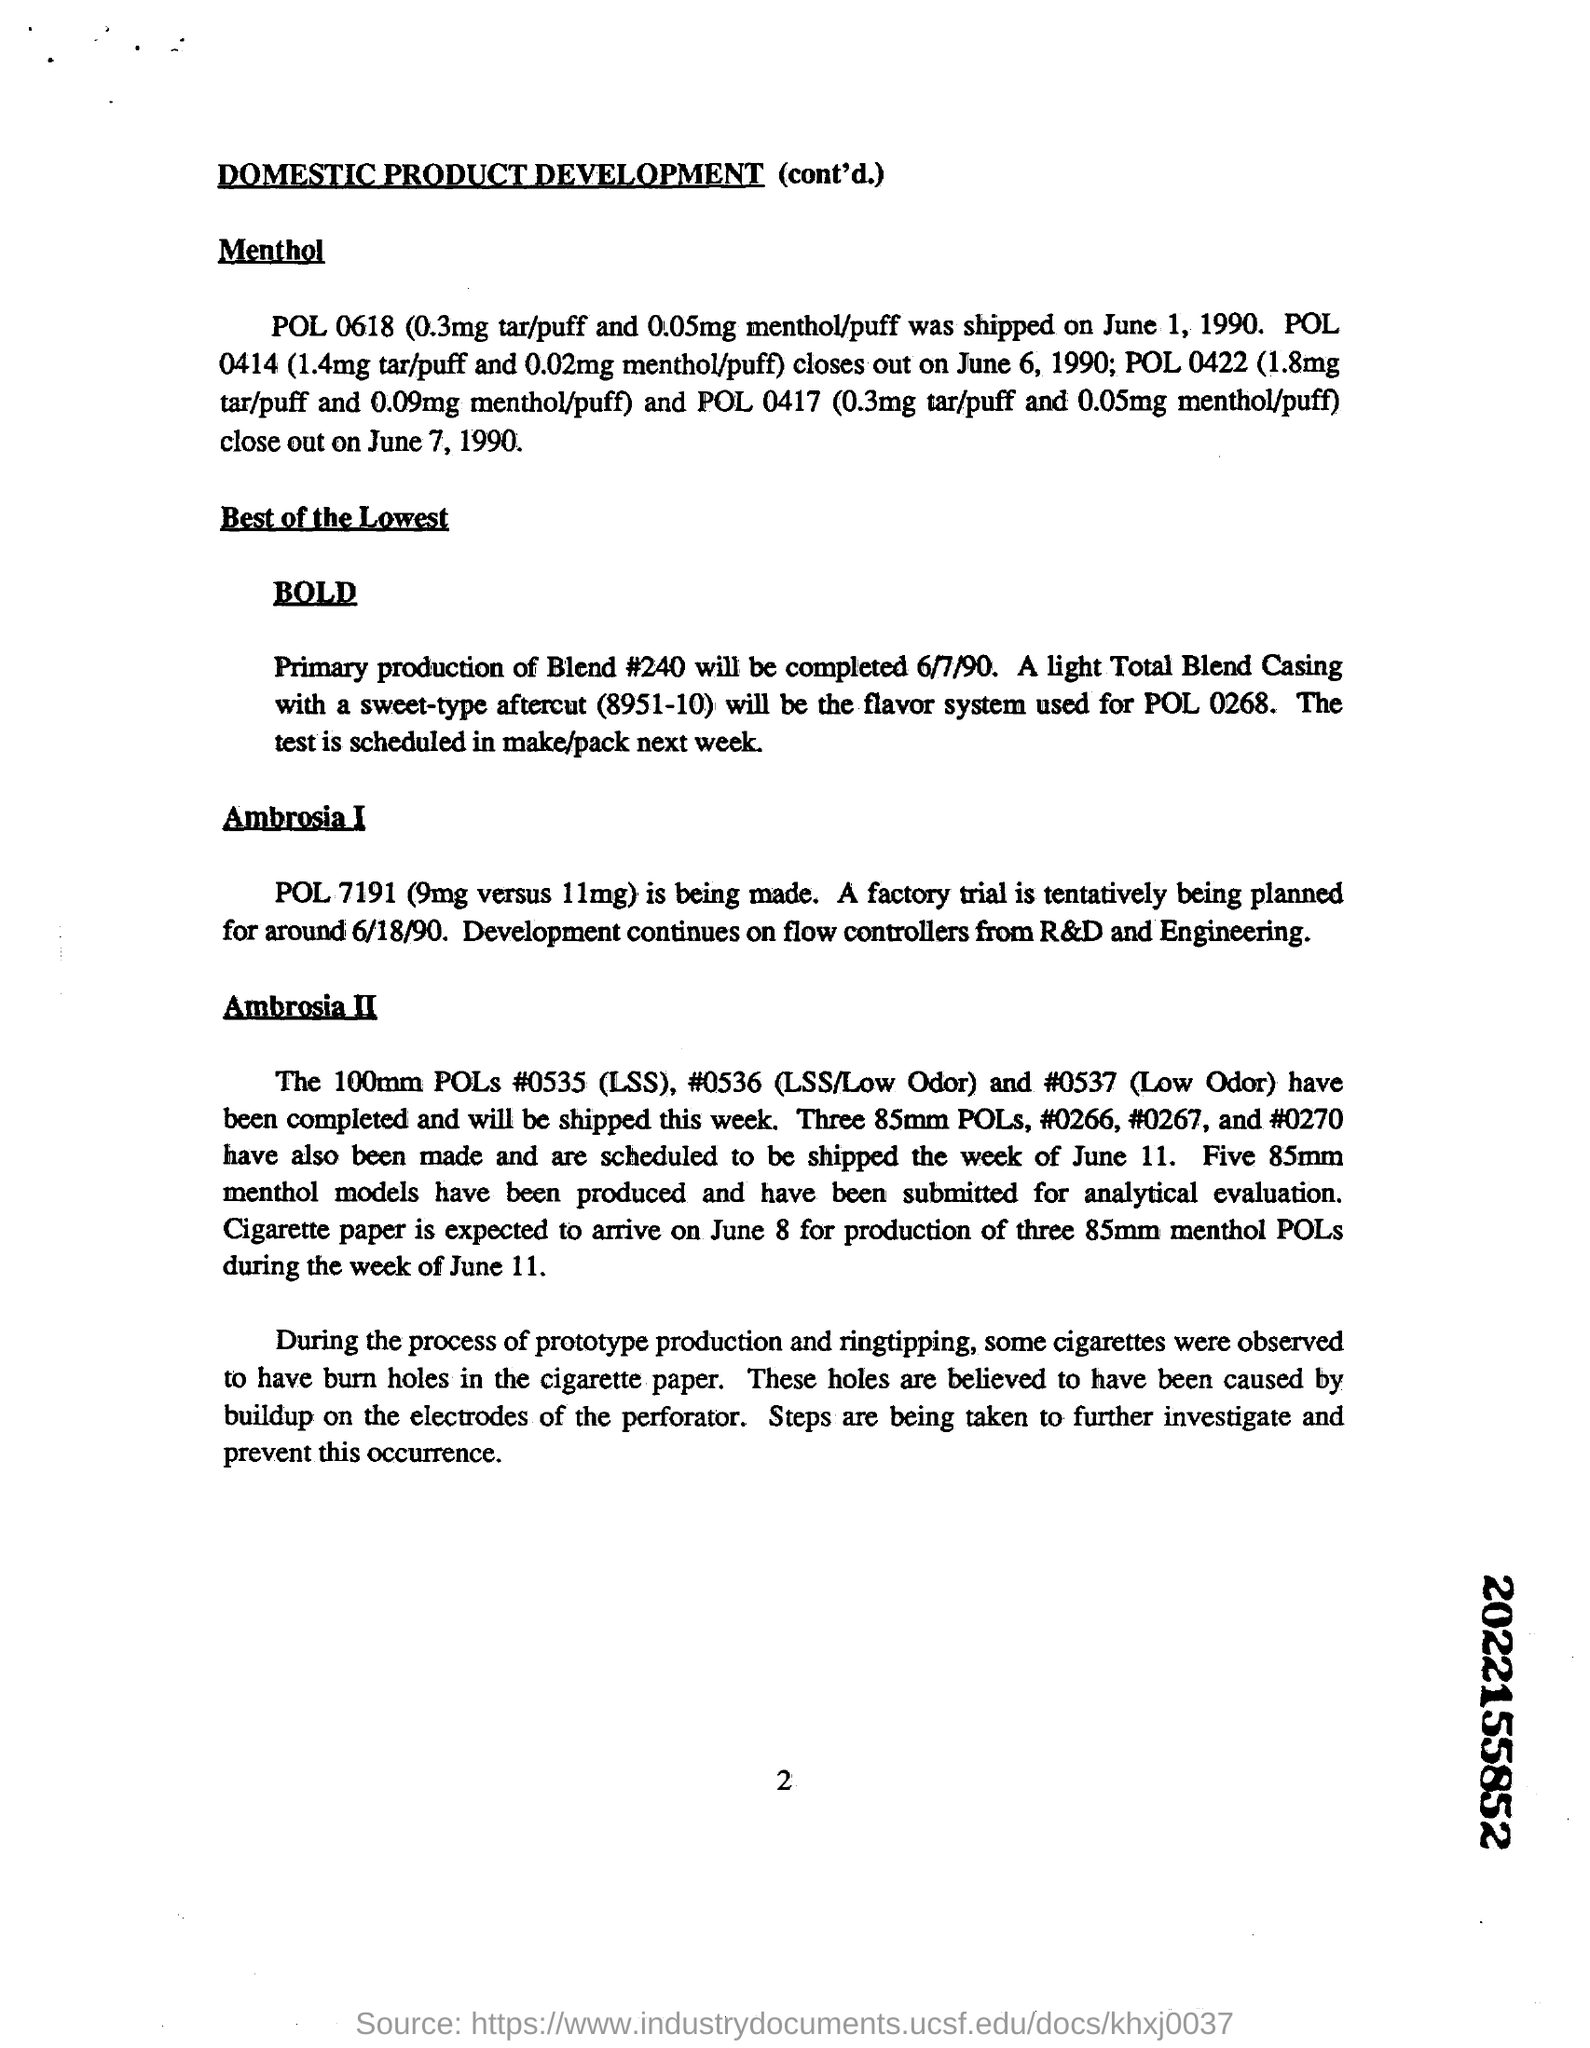Under BOLD, primary production of Blend #24- will be completed by which date
Offer a very short reply. 6/7/90. During the process of prototype production and ringtipping, some cigarettes were observed to have burn holed in which paper
Your answer should be compact. Cigarette paper. 